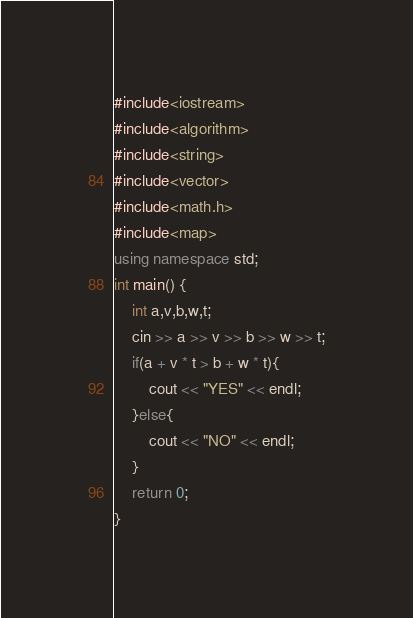Convert code to text. <code><loc_0><loc_0><loc_500><loc_500><_C++_>#include<iostream>
#include<algorithm>
#include<string>
#include<vector>
#include<math.h>
#include<map>
using namespace std;
int main() {
    int a,v,b,w,t;
    cin >> a >> v >> b >> w >> t;
    if(a + v * t > b + w * t){
        cout << "YES" << endl;
    }else{
        cout << "NO" << endl;
    }
    return 0;
}</code> 